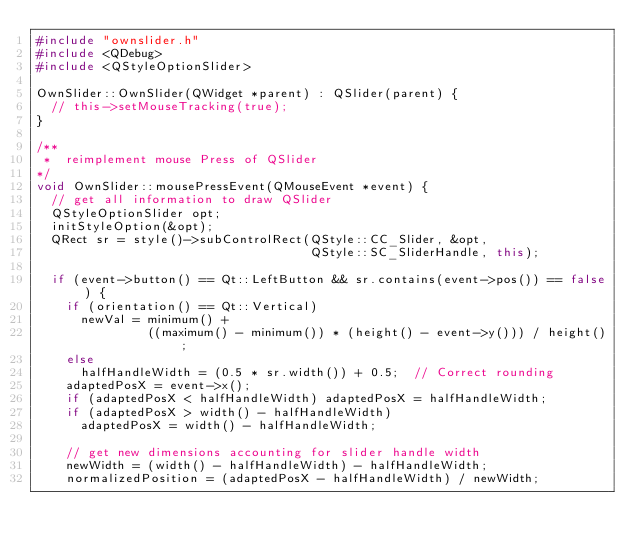<code> <loc_0><loc_0><loc_500><loc_500><_C++_>#include "ownslider.h"
#include <QDebug>
#include <QStyleOptionSlider>

OwnSlider::OwnSlider(QWidget *parent) : QSlider(parent) {
  // this->setMouseTracking(true);
}

/**
 *  reimplement mouse Press of QSlider
*/
void OwnSlider::mousePressEvent(QMouseEvent *event) {
  // get all information to draw QSlider
  QStyleOptionSlider opt;
  initStyleOption(&opt);
  QRect sr = style()->subControlRect(QStyle::CC_Slider, &opt,
                                     QStyle::SC_SliderHandle, this);

  if (event->button() == Qt::LeftButton && sr.contains(event->pos()) == false) {
    if (orientation() == Qt::Vertical)
      newVal = minimum() +
               ((maximum() - minimum()) * (height() - event->y())) / height();
    else
      halfHandleWidth = (0.5 * sr.width()) + 0.5;  // Correct rounding
    adaptedPosX = event->x();
    if (adaptedPosX < halfHandleWidth) adaptedPosX = halfHandleWidth;
    if (adaptedPosX > width() - halfHandleWidth)
      adaptedPosX = width() - halfHandleWidth;

    // get new dimensions accounting for slider handle width
    newWidth = (width() - halfHandleWidth) - halfHandleWidth;
    normalizedPosition = (adaptedPosX - halfHandleWidth) / newWidth;
</code> 